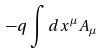Convert formula to latex. <formula><loc_0><loc_0><loc_500><loc_500>- q \int d x ^ { \mu } A _ { \mu }</formula> 